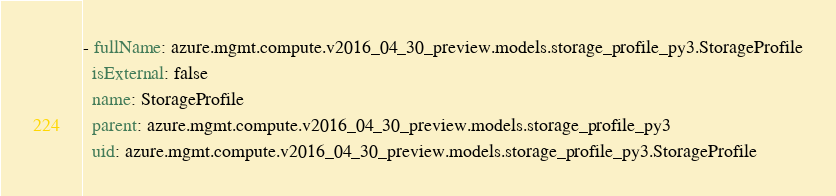<code> <loc_0><loc_0><loc_500><loc_500><_YAML_>- fullName: azure.mgmt.compute.v2016_04_30_preview.models.storage_profile_py3.StorageProfile
  isExternal: false
  name: StorageProfile
  parent: azure.mgmt.compute.v2016_04_30_preview.models.storage_profile_py3
  uid: azure.mgmt.compute.v2016_04_30_preview.models.storage_profile_py3.StorageProfile
</code> 